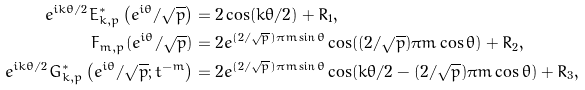<formula> <loc_0><loc_0><loc_500><loc_500>e ^ { i k \theta / 2 } E _ { k , p } ^ { * } \left ( e ^ { i \theta } / \sqrt { p } \right ) & = 2 \cos ( k \theta / 2 ) + R _ { 1 } , \\ F _ { m , p } ( e ^ { i \theta } / \sqrt { p } ) & = 2 e ^ { ( 2 / \sqrt { p } ) \pi m \sin \theta } \cos ( ( 2 / \sqrt { p } ) \pi m \cos \theta ) + R _ { 2 } , \\ e ^ { i k \theta / 2 } G _ { k , p } ^ { * } \left ( e ^ { i \theta } / \sqrt { p } ; t ^ { - m } \right ) & = 2 e ^ { ( 2 / \sqrt { p } ) \pi m \sin \theta } \cos ( k \theta / 2 - ( 2 / \sqrt { p } ) \pi m \cos \theta ) + R _ { 3 } ,</formula> 